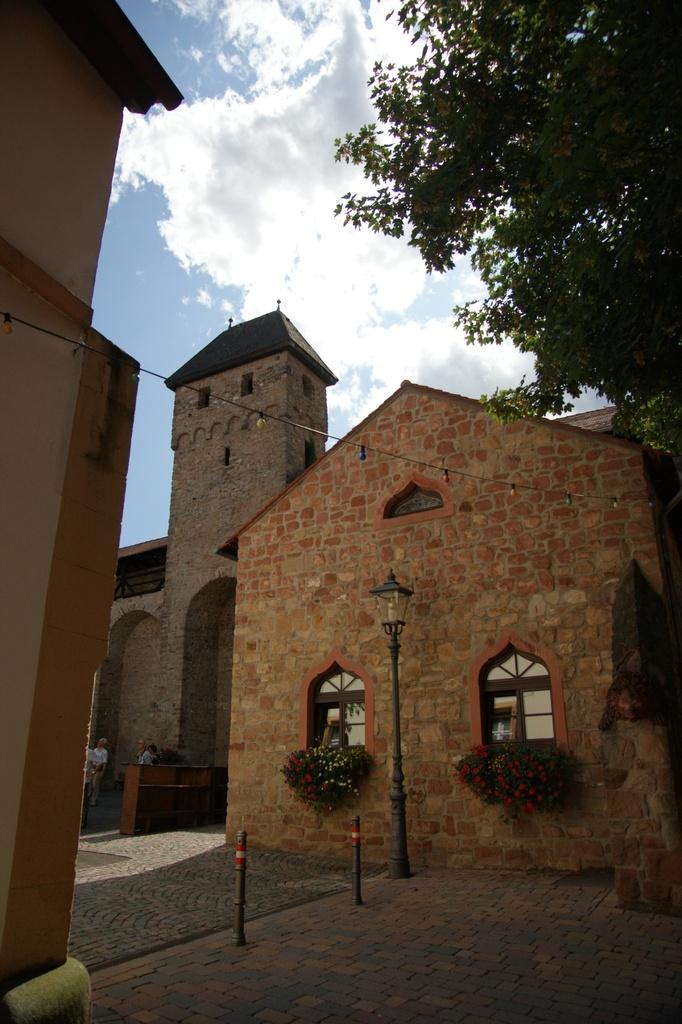What color are the buildings in the image? The buildings in the image are in brown color. What other object can be seen in the image besides the buildings? There is a light pole in the image. What type of vegetation is present in the image? There are trees in green color in the image. What colors are visible in the background sky? The background sky is in white and blue color. How many men are holding glue in the image? There are no men or glue present in the image. What type of picture is depicted on the trees in the image? There is no picture present on the trees in the image; they are simply green trees. 